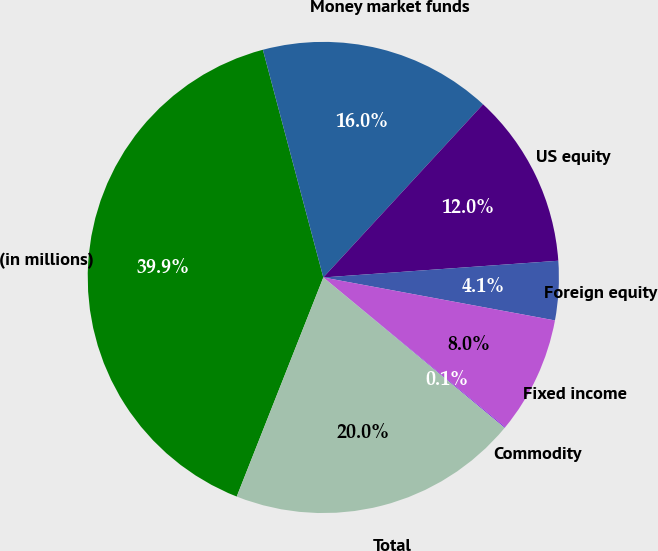<chart> <loc_0><loc_0><loc_500><loc_500><pie_chart><fcel>(in millions)<fcel>Money market funds<fcel>US equity<fcel>Foreign equity<fcel>Fixed income<fcel>Commodity<fcel>Total<nl><fcel>39.88%<fcel>15.99%<fcel>12.01%<fcel>4.05%<fcel>8.03%<fcel>0.07%<fcel>19.97%<nl></chart> 